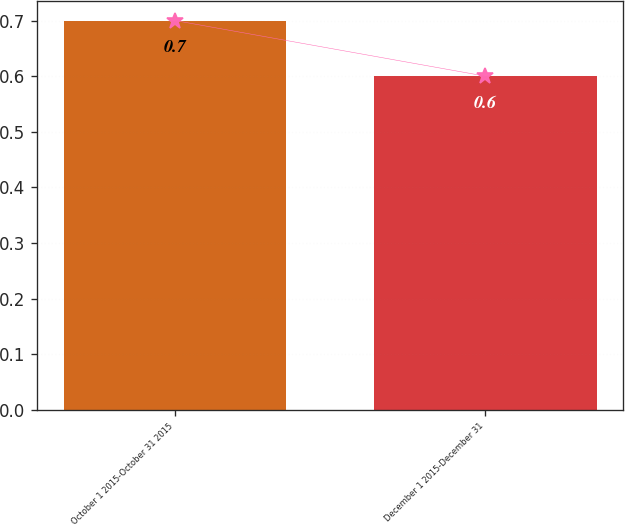Convert chart to OTSL. <chart><loc_0><loc_0><loc_500><loc_500><bar_chart><fcel>October 1 2015-October 31 2015<fcel>December 1 2015-December 31<nl><fcel>0.7<fcel>0.6<nl></chart> 